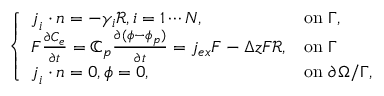Convert formula to latex. <formula><loc_0><loc_0><loc_500><loc_500>\left \{ \begin{array} { l l } { j _ { i } \cdot n = - \gamma _ { i } \mathcal { R } , i = 1 \cdots N , } & { o n \Gamma , } \\ { F \frac { \partial C _ { e } } { \partial t } = \mathbb { C } _ { p } \frac { \partial ( \phi - \phi _ { p } ) } { \partial t } = j _ { e x } F - \Delta z F \mathcal { R } , } & { o n \Gamma } \\ { j _ { i } \cdot n = 0 , \phi = 0 , } & { o n \partial \Omega / \Gamma , } \end{array}</formula> 